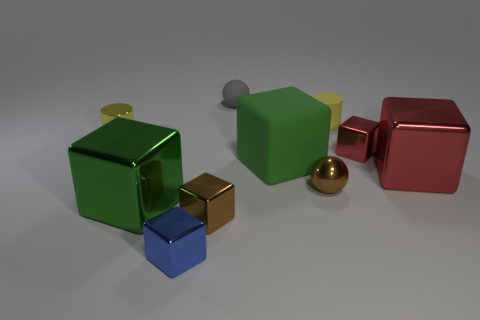Is the color of the metal cylinder the same as the large metal block that is to the left of the large matte thing?
Give a very brief answer. No. What is the material of the green object that is right of the gray sphere?
Keep it short and to the point. Rubber. Is there a metallic cylinder that has the same color as the matte sphere?
Provide a succinct answer. No. There is a shiny sphere that is the same size as the yellow matte cylinder; what color is it?
Your answer should be compact. Brown. What number of large objects are green metal objects or red metallic things?
Your answer should be compact. 2. Are there an equal number of small matte spheres that are in front of the small yellow rubber thing and balls left of the big matte thing?
Give a very brief answer. No. How many brown metal objects have the same size as the yellow shiny object?
Provide a succinct answer. 2. How many gray objects are tiny balls or large shiny blocks?
Your response must be concise. 1. Are there an equal number of large green matte blocks to the left of the large green metal cube and small yellow rubber objects?
Offer a terse response. No. How big is the cylinder that is right of the blue metal block?
Keep it short and to the point. Small. 